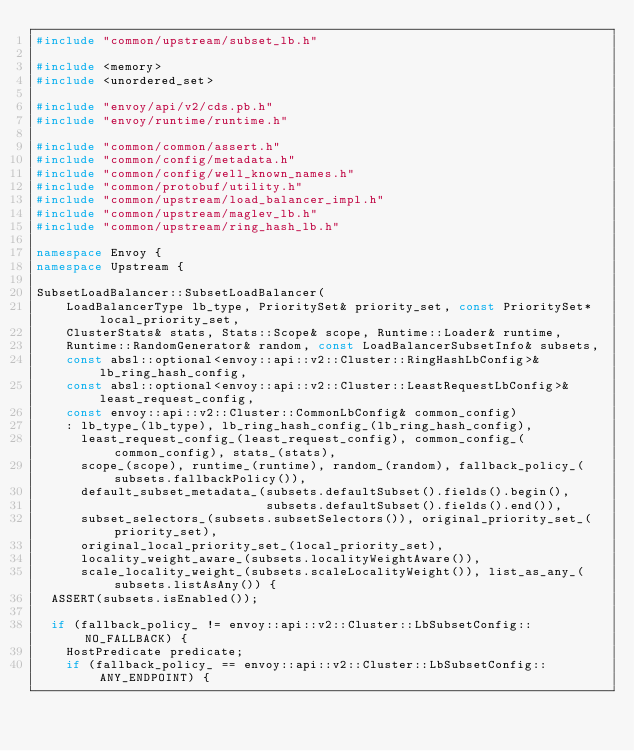Convert code to text. <code><loc_0><loc_0><loc_500><loc_500><_C++_>#include "common/upstream/subset_lb.h"

#include <memory>
#include <unordered_set>

#include "envoy/api/v2/cds.pb.h"
#include "envoy/runtime/runtime.h"

#include "common/common/assert.h"
#include "common/config/metadata.h"
#include "common/config/well_known_names.h"
#include "common/protobuf/utility.h"
#include "common/upstream/load_balancer_impl.h"
#include "common/upstream/maglev_lb.h"
#include "common/upstream/ring_hash_lb.h"

namespace Envoy {
namespace Upstream {

SubsetLoadBalancer::SubsetLoadBalancer(
    LoadBalancerType lb_type, PrioritySet& priority_set, const PrioritySet* local_priority_set,
    ClusterStats& stats, Stats::Scope& scope, Runtime::Loader& runtime,
    Runtime::RandomGenerator& random, const LoadBalancerSubsetInfo& subsets,
    const absl::optional<envoy::api::v2::Cluster::RingHashLbConfig>& lb_ring_hash_config,
    const absl::optional<envoy::api::v2::Cluster::LeastRequestLbConfig>& least_request_config,
    const envoy::api::v2::Cluster::CommonLbConfig& common_config)
    : lb_type_(lb_type), lb_ring_hash_config_(lb_ring_hash_config),
      least_request_config_(least_request_config), common_config_(common_config), stats_(stats),
      scope_(scope), runtime_(runtime), random_(random), fallback_policy_(subsets.fallbackPolicy()),
      default_subset_metadata_(subsets.defaultSubset().fields().begin(),
                               subsets.defaultSubset().fields().end()),
      subset_selectors_(subsets.subsetSelectors()), original_priority_set_(priority_set),
      original_local_priority_set_(local_priority_set),
      locality_weight_aware_(subsets.localityWeightAware()),
      scale_locality_weight_(subsets.scaleLocalityWeight()), list_as_any_(subsets.listAsAny()) {
  ASSERT(subsets.isEnabled());

  if (fallback_policy_ != envoy::api::v2::Cluster::LbSubsetConfig::NO_FALLBACK) {
    HostPredicate predicate;
    if (fallback_policy_ == envoy::api::v2::Cluster::LbSubsetConfig::ANY_ENDPOINT) {</code> 